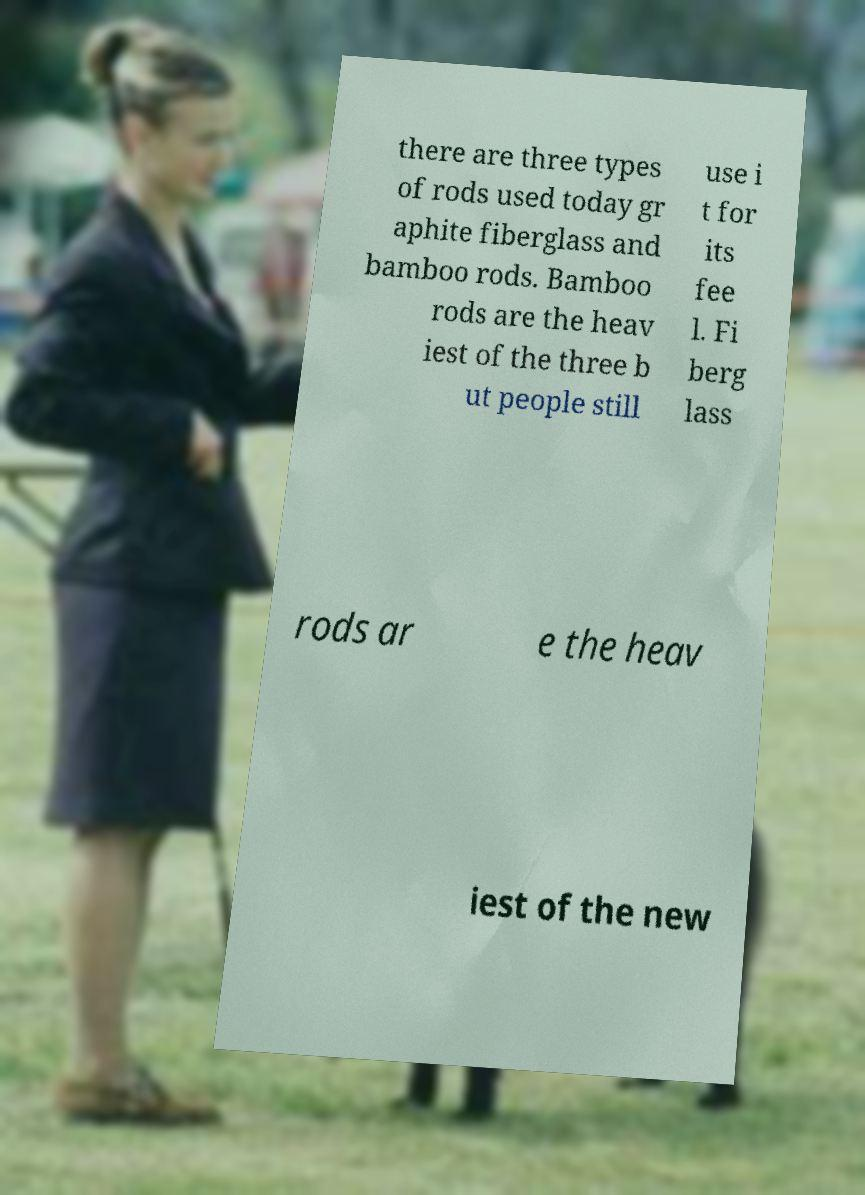What messages or text are displayed in this image? I need them in a readable, typed format. there are three types of rods used today gr aphite fiberglass and bamboo rods. Bamboo rods are the heav iest of the three b ut people still use i t for its fee l. Fi berg lass rods ar e the heav iest of the new 